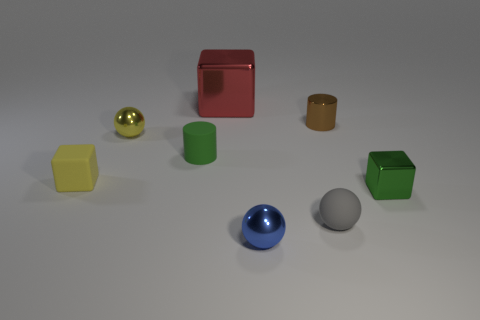What number of rubber cylinders are the same color as the big metal cube?
Your response must be concise. 0. What is the color of the metal sphere that is behind the small metal thing that is right of the small cylinder that is right of the red metallic cube?
Make the answer very short. Yellow. Do the tiny blue object and the yellow ball have the same material?
Ensure brevity in your answer.  Yes. Is the red metallic object the same shape as the small green metal thing?
Your answer should be very brief. Yes. Are there the same number of tiny yellow metal spheres to the right of the brown cylinder and small blue metallic balls that are behind the red shiny cube?
Keep it short and to the point. Yes. There is a small cube that is the same material as the small brown cylinder; what color is it?
Make the answer very short. Green. What number of blue balls have the same material as the tiny blue object?
Offer a very short reply. 0. Do the small cube that is on the right side of the brown object and the large shiny thing have the same color?
Give a very brief answer. No. What number of small gray rubber objects have the same shape as the big thing?
Give a very brief answer. 0. Is the number of cylinders that are on the left side of the tiny brown shiny object the same as the number of shiny things?
Your response must be concise. No. 